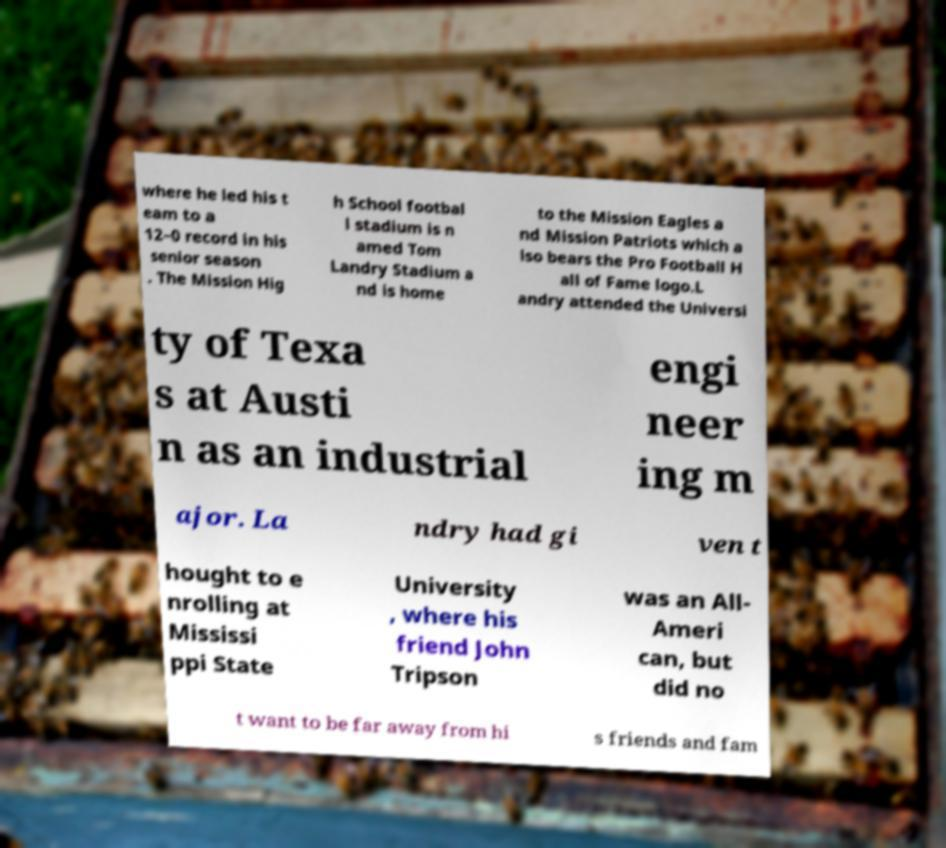Could you extract and type out the text from this image? where he led his t eam to a 12–0 record in his senior season . The Mission Hig h School footbal l stadium is n amed Tom Landry Stadium a nd is home to the Mission Eagles a nd Mission Patriots which a lso bears the Pro Football H all of Fame logo.L andry attended the Universi ty of Texa s at Austi n as an industrial engi neer ing m ajor. La ndry had gi ven t hought to e nrolling at Mississi ppi State University , where his friend John Tripson was an All- Ameri can, but did no t want to be far away from hi s friends and fam 